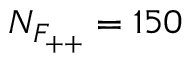Convert formula to latex. <formula><loc_0><loc_0><loc_500><loc_500>N _ { F _ { + + } } = 1 5 0</formula> 